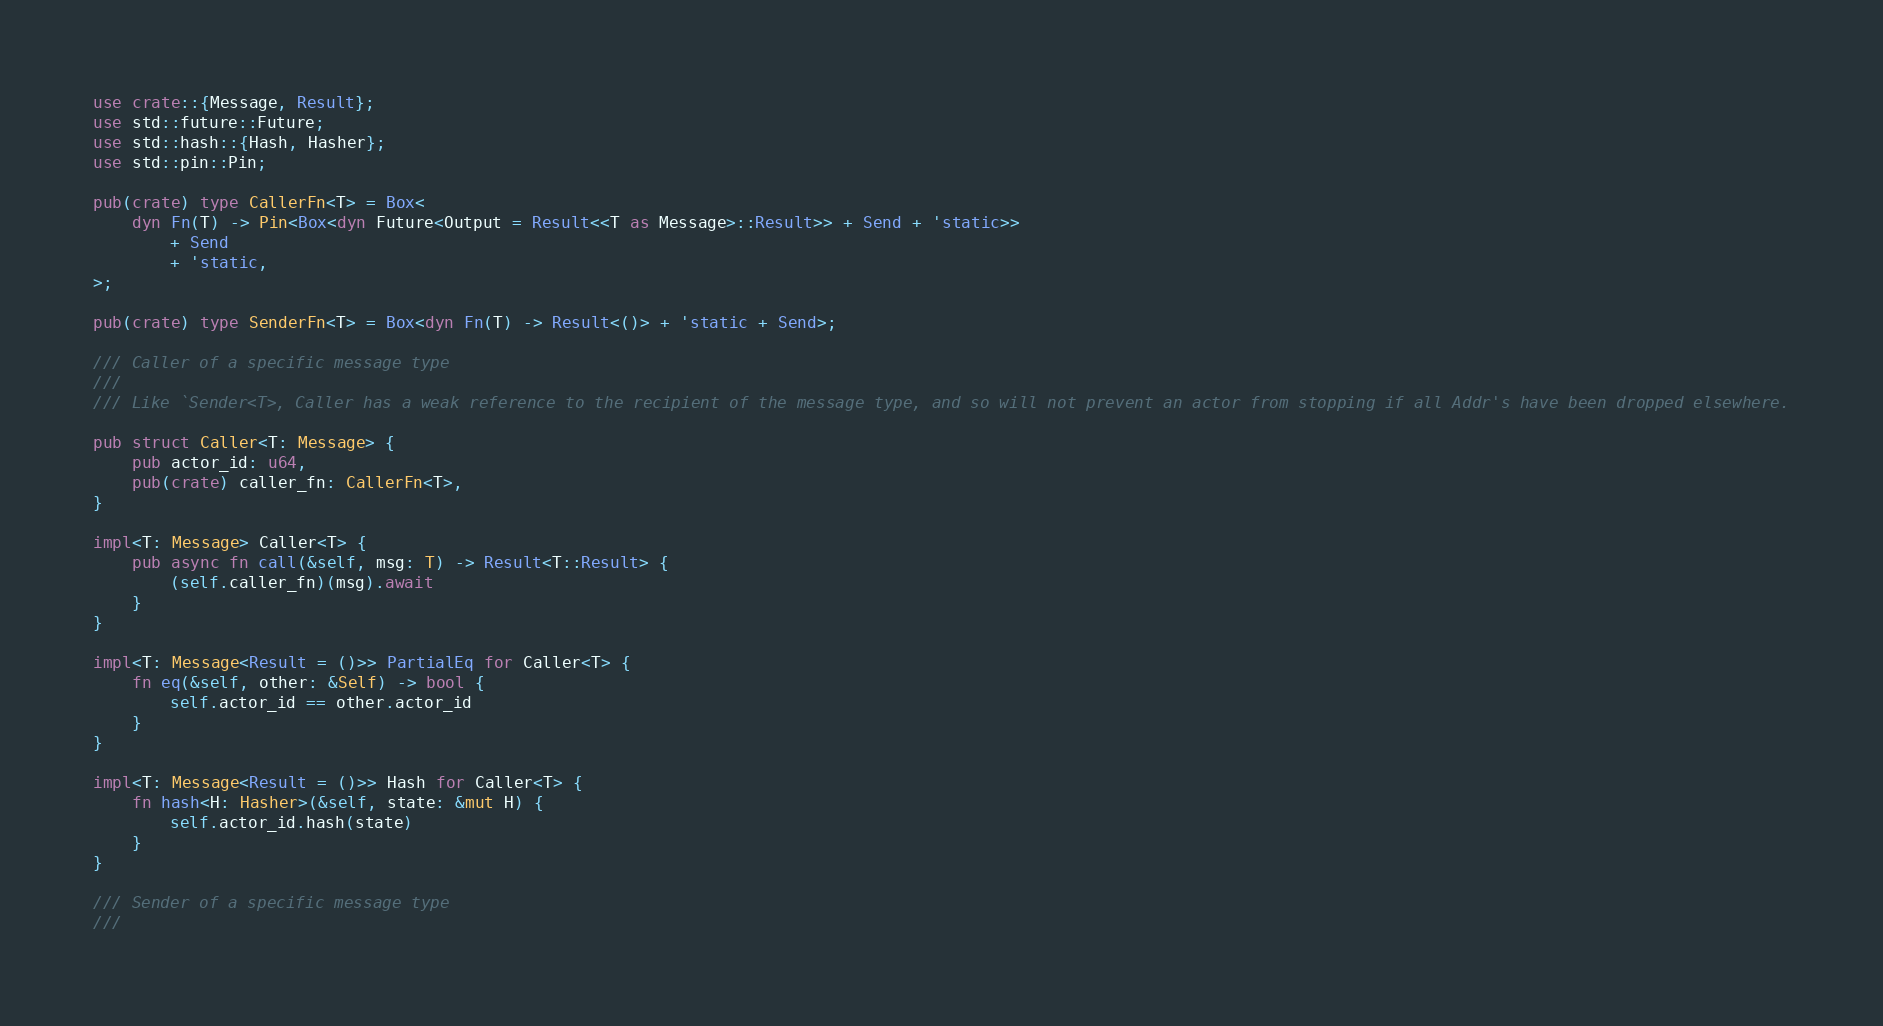<code> <loc_0><loc_0><loc_500><loc_500><_Rust_>use crate::{Message, Result};
use std::future::Future;
use std::hash::{Hash, Hasher};
use std::pin::Pin;

pub(crate) type CallerFn<T> = Box<
    dyn Fn(T) -> Pin<Box<dyn Future<Output = Result<<T as Message>::Result>> + Send + 'static>>
        + Send
        + 'static,
>;

pub(crate) type SenderFn<T> = Box<dyn Fn(T) -> Result<()> + 'static + Send>;

/// Caller of a specific message type
///
/// Like `Sender<T>, Caller has a weak reference to the recipient of the message type, and so will not prevent an actor from stopping if all Addr's have been dropped elsewhere.

pub struct Caller<T: Message> {
    pub actor_id: u64,
    pub(crate) caller_fn: CallerFn<T>,
}

impl<T: Message> Caller<T> {
    pub async fn call(&self, msg: T) -> Result<T::Result> {
        (self.caller_fn)(msg).await
    }
}

impl<T: Message<Result = ()>> PartialEq for Caller<T> {
    fn eq(&self, other: &Self) -> bool {
        self.actor_id == other.actor_id
    }
}

impl<T: Message<Result = ()>> Hash for Caller<T> {
    fn hash<H: Hasher>(&self, state: &mut H) {
        self.actor_id.hash(state)
    }
}

/// Sender of a specific message type
///</code> 